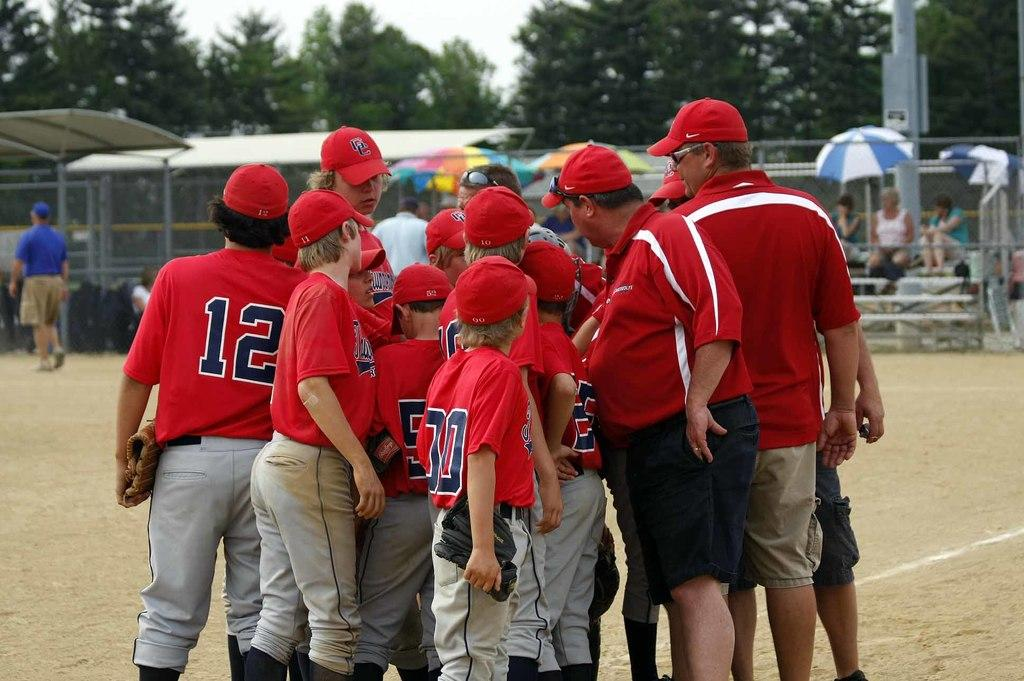Provide a one-sentence caption for the provided image. A baseball player with the number 12 on his jersey with a group of other baseball players. 